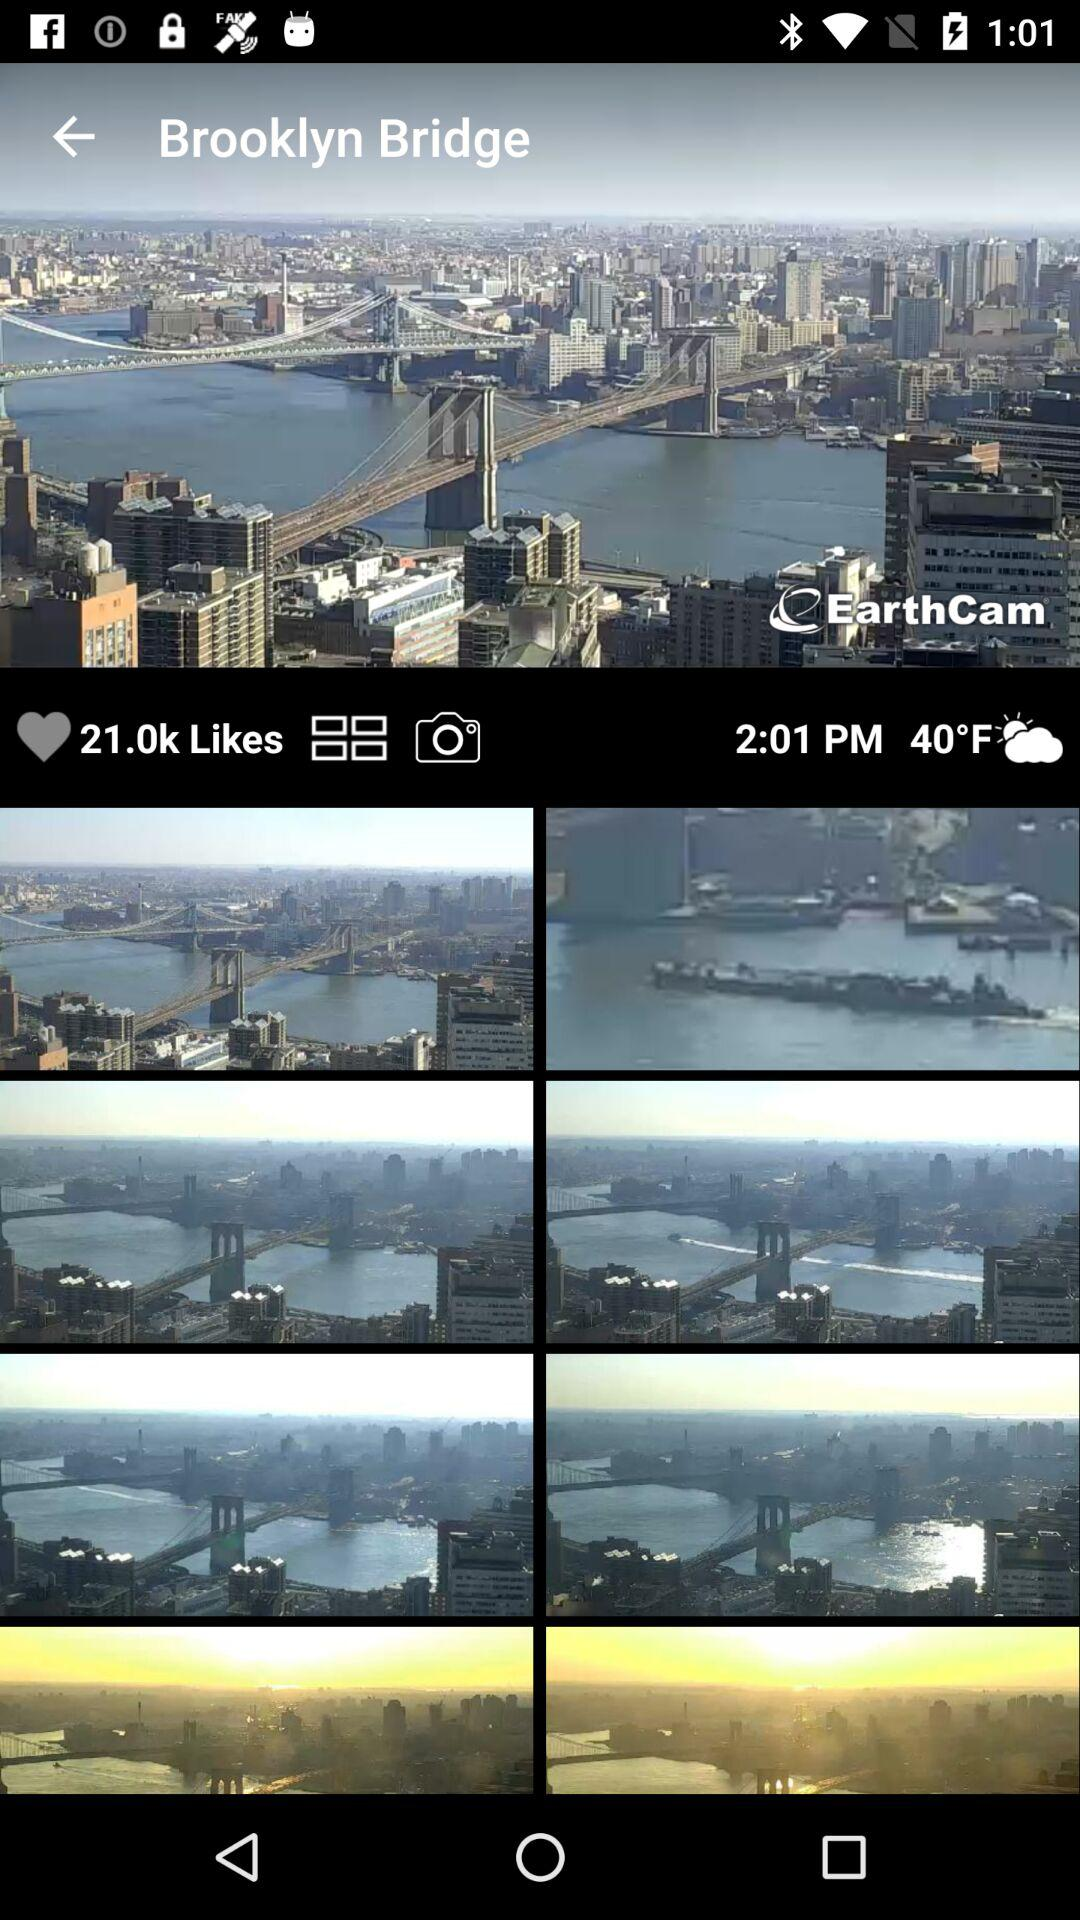What is the count of likes? The count of likes is 21.0k. 